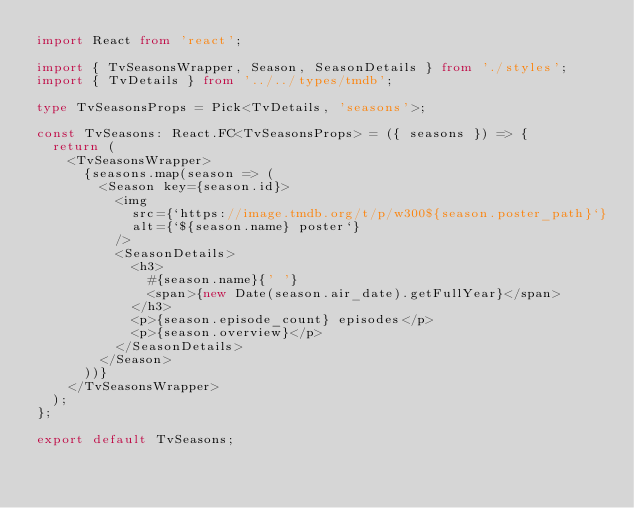<code> <loc_0><loc_0><loc_500><loc_500><_TypeScript_>import React from 'react';

import { TvSeasonsWrapper, Season, SeasonDetails } from './styles';
import { TvDetails } from '../../types/tmdb';

type TvSeasonsProps = Pick<TvDetails, 'seasons'>;

const TvSeasons: React.FC<TvSeasonsProps> = ({ seasons }) => {
  return (
    <TvSeasonsWrapper>
      {seasons.map(season => (
        <Season key={season.id}>
          <img
            src={`https://image.tmdb.org/t/p/w300${season.poster_path}`}
            alt={`${season.name} poster`}
          />
          <SeasonDetails>
            <h3>
              #{season.name}{' '}
              <span>{new Date(season.air_date).getFullYear}</span>
            </h3>
            <p>{season.episode_count} episodes</p>
            <p>{season.overview}</p>
          </SeasonDetails>
        </Season>
      ))}
    </TvSeasonsWrapper>
  );
};

export default TvSeasons;
</code> 